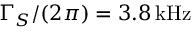Convert formula to latex. <formula><loc_0><loc_0><loc_500><loc_500>\Gamma _ { S } / ( 2 \pi ) = 3 . 8 \, k H z</formula> 